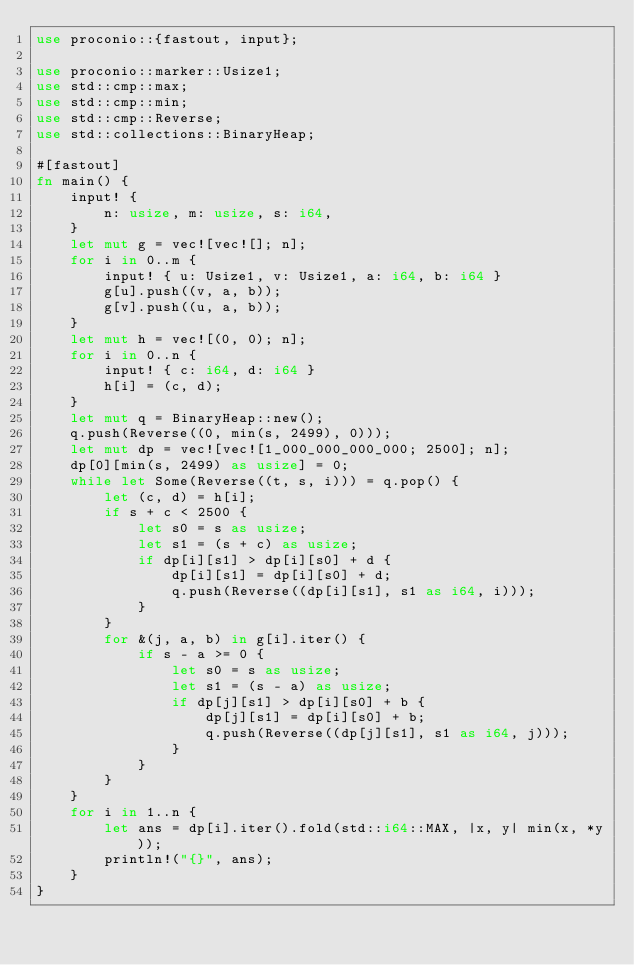Convert code to text. <code><loc_0><loc_0><loc_500><loc_500><_Rust_>use proconio::{fastout, input};

use proconio::marker::Usize1;
use std::cmp::max;
use std::cmp::min;
use std::cmp::Reverse;
use std::collections::BinaryHeap;

#[fastout]
fn main() {
    input! {
        n: usize, m: usize, s: i64,
    }
    let mut g = vec![vec![]; n];
    for i in 0..m {
        input! { u: Usize1, v: Usize1, a: i64, b: i64 }
        g[u].push((v, a, b));
        g[v].push((u, a, b));
    }
    let mut h = vec![(0, 0); n];
    for i in 0..n {
        input! { c: i64, d: i64 }
        h[i] = (c, d);
    }
    let mut q = BinaryHeap::new();
    q.push(Reverse((0, min(s, 2499), 0)));
    let mut dp = vec![vec![1_000_000_000_000; 2500]; n];
    dp[0][min(s, 2499) as usize] = 0;
    while let Some(Reverse((t, s, i))) = q.pop() {
        let (c, d) = h[i];
        if s + c < 2500 {
            let s0 = s as usize;
            let s1 = (s + c) as usize;
            if dp[i][s1] > dp[i][s0] + d {
                dp[i][s1] = dp[i][s0] + d;
                q.push(Reverse((dp[i][s1], s1 as i64, i)));
            }
        }
        for &(j, a, b) in g[i].iter() {
            if s - a >= 0 {
                let s0 = s as usize;
                let s1 = (s - a) as usize;
                if dp[j][s1] > dp[i][s0] + b {
                    dp[j][s1] = dp[i][s0] + b;
                    q.push(Reverse((dp[j][s1], s1 as i64, j)));
                }
            }
        }
    }
    for i in 1..n {
        let ans = dp[i].iter().fold(std::i64::MAX, |x, y| min(x, *y));
        println!("{}", ans);
    }
}
</code> 